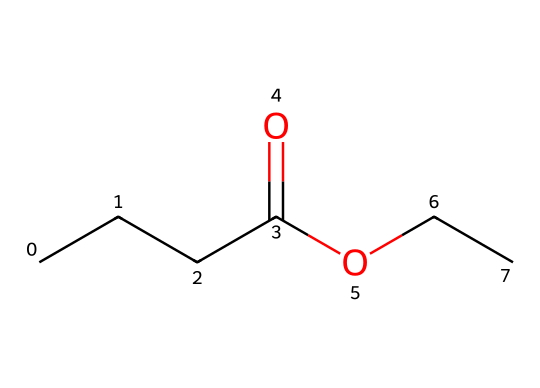What is the molecular formula of ethyl butyrate? To derive the molecular formula from the SMILES representation, count the carbon (C), hydrogen (H), and oxygen (O) atoms. In the SMILES, there are 4 carbons from the butyric acid part and 2 carbons from the ethyl group, totaling 6 carbons (C6). Count 12 hydrogens (H12) and 2 oxygens (O2). Therefore, the molecular formula is C6H12O2.
Answer: C6H12O2 How many carbon atoms are present in ethyl butyrate? From the SMILES representation, count the carbon atoms. There are a total of 6 carbon atoms indicated in the structure.
Answer: 6 What type of functional groups are present in ethyl butyrate? The SMILES shows a carboxylic acid derivative and an ester, indicated by the C(=O)O part. The carbonyl (C=O) indicates it's part of a carboxylic acid, and the OR part signifies it is an ester. Thus, the functional groups are an ester and a carboxylic acid.
Answer: ester, carboxylic acid Why is ethyl butyrate used in energy drinks? Ethyl butyrate has a pineapple-like flavor that gives drinks a pleasant aroma and taste, making them more appealing. This aromatic property is a characteristic of many esters, which enhance flavors in various beverages.
Answer: pineapple-like flavor Is ethyl butyrate a natural or synthetic flavor? Ethyl butyrate can occur naturally in various fruits but is also produced synthetically, often mimicking the natural compounds found in fruits to enhance flavoring in food products, including energy drinks.
Answer: both What type of flavor does ethyl butyrate impart? Ethyl butyrate is known for imparting a fruity flavor, particularly reminiscent of pineapple and other tropical fruits, which aligns with its use in enhancing flavors in beverages.
Answer: fruity 